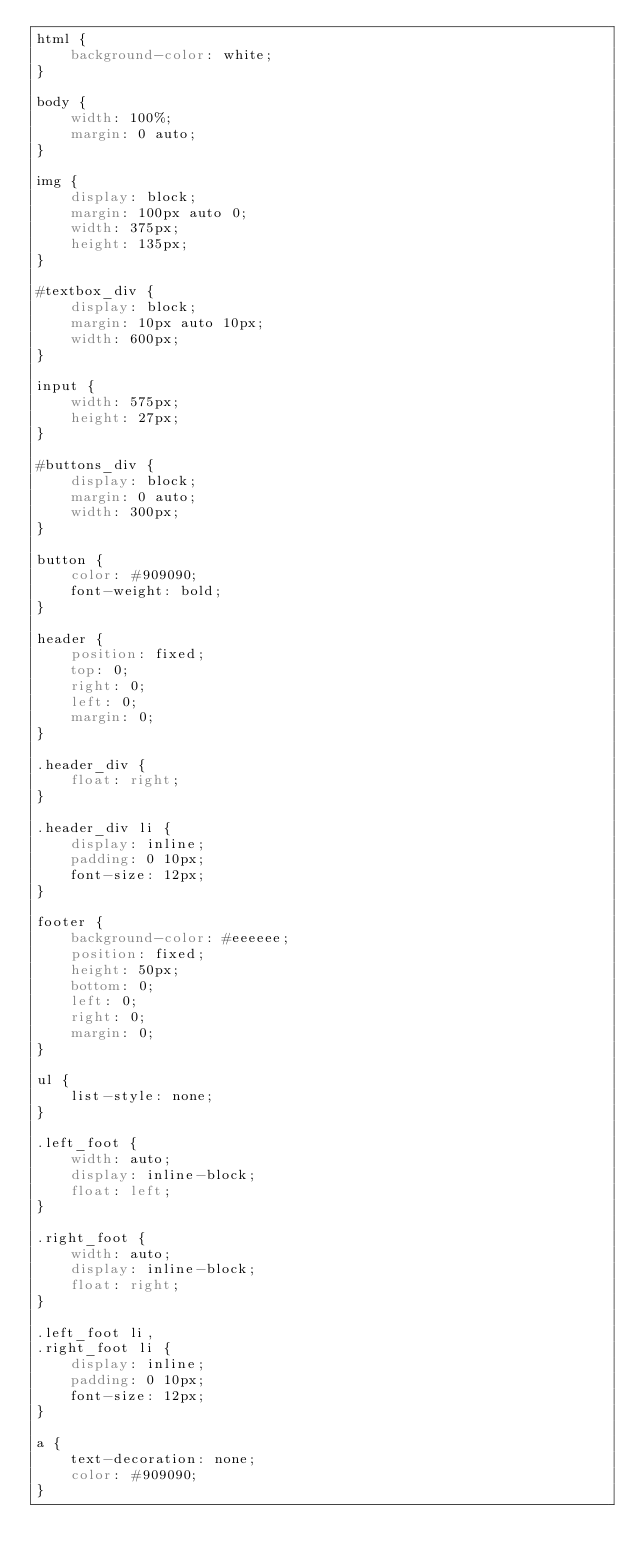<code> <loc_0><loc_0><loc_500><loc_500><_CSS_>html {
    background-color: white;
}

body {
    width: 100%;
    margin: 0 auto;
}

img {
    display: block;
    margin: 100px auto 0;
    width: 375px;
    height: 135px;
}

#textbox_div {
    display: block;
    margin: 10px auto 10px;
    width: 600px;
}

input {
    width: 575px;
    height: 27px;
}

#buttons_div {
    display: block;
    margin: 0 auto;
    width: 300px;
}

button {
    color: #909090;
    font-weight: bold;
}

header {
    position: fixed;
    top: 0;
    right: 0;
    left: 0;
    margin: 0;
}

.header_div {
    float: right;
}

.header_div li {
    display: inline;
    padding: 0 10px;
    font-size: 12px;
}

footer {
    background-color: #eeeeee;
    position: fixed;
    height: 50px;
    bottom: 0;
    left: 0;
    right: 0;
    margin: 0;
}

ul {
    list-style: none;
}

.left_foot {
    width: auto;
    display: inline-block;
    float: left;
}

.right_foot {
    width: auto;
    display: inline-block;
    float: right;
}

.left_foot li,
.right_foot li {
    display: inline;
    padding: 0 10px;
    font-size: 12px;
}

a {
    text-decoration: none;
    color: #909090;
}</code> 